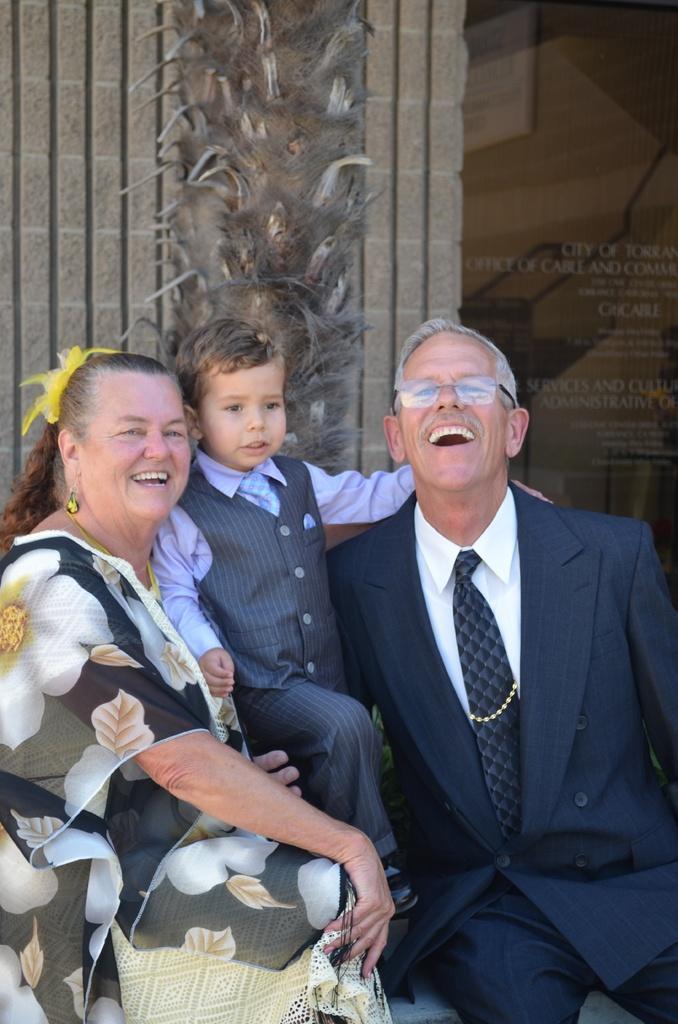Please provide a concise description of this image. In this image there is a man, woman and a boy, in the background there is a wall on that wall some text is written. 